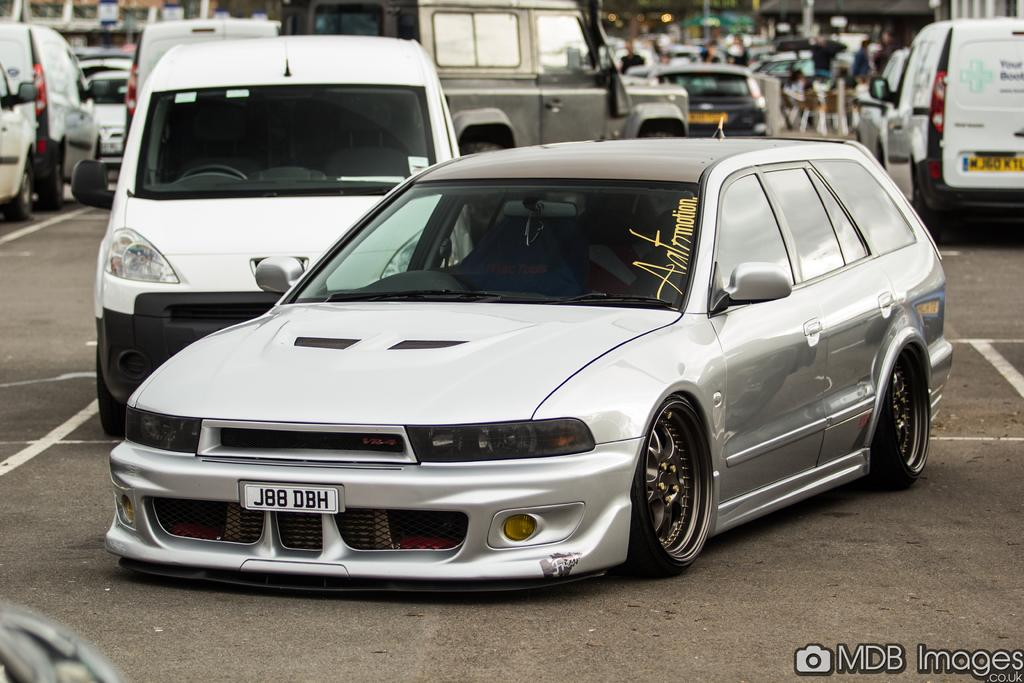What can be seen in the image? There is a group of vehicles and people in the image. What is the setting of the image? There are buildings in the background of the image, and there is a road at the bottom of the image. What type of yoke can be seen in the image? There is no yoke present in the image. Is there a band playing music in the image? There is no band playing music in the image. 